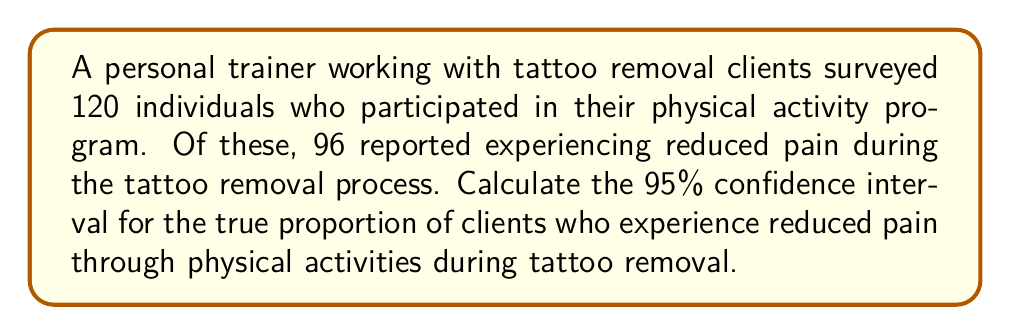Can you solve this math problem? Let's approach this step-by-step:

1) First, we need to calculate the sample proportion:
   $\hat{p} = \frac{\text{number of successes}}{\text{total sample size}} = \frac{96}{120} = 0.8$

2) The formula for the confidence interval of a proportion is:
   $$\hat{p} \pm z_{\alpha/2} \sqrt{\frac{\hat{p}(1-\hat{p})}{n}}$$
   where $z_{\alpha/2}$ is the critical value for the desired confidence level.

3) For a 95% confidence interval, $z_{\alpha/2} = 1.96$

4) Now, let's substitute our values:
   $n = 120$
   $\hat{p} = 0.8$

5) Calculate the standard error:
   $$SE = \sqrt{\frac{\hat{p}(1-\hat{p})}{n}} = \sqrt{\frac{0.8(1-0.8)}{120}} = \sqrt{\frac{0.16}{120}} = 0.0365$$

6) Now we can calculate the margin of error:
   $$ME = 1.96 \times 0.0365 = 0.0715$$

7) Finally, we can compute the confidence interval:
   Lower bound: $0.8 - 0.0715 = 0.7285$
   Upper bound: $0.8 + 0.0715 = 0.8715$

Therefore, we are 95% confident that the true proportion of clients experiencing reduced pain through physical activities during tattoo removal is between 0.7285 and 0.8715, or approximately 72.85% to 87.15%.
Answer: (0.7285, 0.8715) 